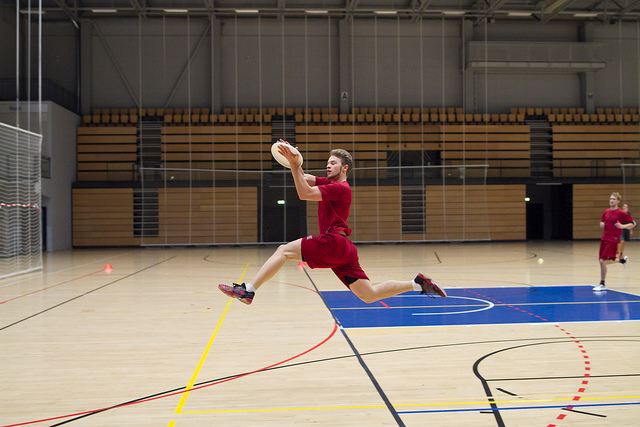<image>What is the score? It is unknown what the score is. It can be '0 0', '20', or '1 to 0'. What is the score? It is unknown what the score is. 